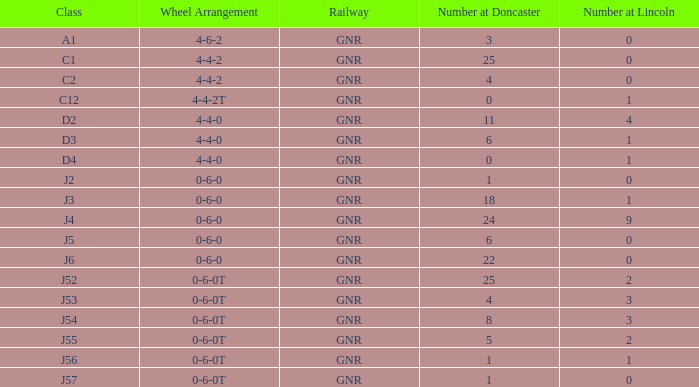Which Class has a Number at Lincoln smaller than 1 and a Wheel Arrangement of 0-6-0? J2, J5, J6. 